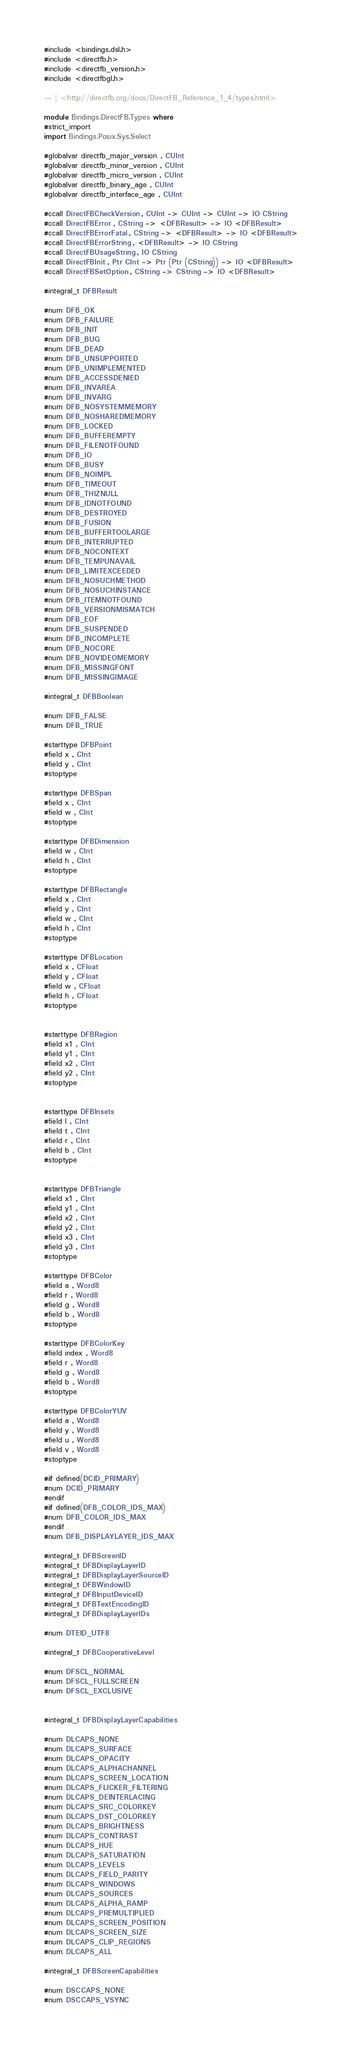Convert code to text. <code><loc_0><loc_0><loc_500><loc_500><_Haskell_>#include <bindings.dsl.h>
#include <directfb.h>
#include <directfb_version.h>
#include <directfbgl.h>

-- | <http://directfb.org/docs/DirectFB_Reference_1_4/types.html>

module Bindings.DirectFB.Types where
#strict_import
import Bindings.Posix.Sys.Select

#globalvar directfb_major_version , CUInt
#globalvar directfb_minor_version , CUInt
#globalvar directfb_micro_version , CUInt
#globalvar directfb_binary_age , CUInt
#globalvar directfb_interface_age , CUInt

#ccall DirectFBCheckVersion , CUInt -> CUInt -> CUInt -> IO CString
#ccall DirectFBError , CString -> <DFBResult> -> IO <DFBResult>
#ccall DirectFBErrorFatal , CString -> <DFBResult> -> IO <DFBResult>
#ccall DirectFBErrorString , <DFBResult> -> IO CString
#ccall DirectFBUsageString , IO CString
#ccall DirectFBInit , Ptr CInt -> Ptr (Ptr (CString)) -> IO <DFBResult>
#ccall DirectFBSetOption , CString -> CString -> IO <DFBResult>

#integral_t DFBResult

#num DFB_OK
#num DFB_FAILURE
#num DFB_INIT
#num DFB_BUG
#num DFB_DEAD
#num DFB_UNSUPPORTED
#num DFB_UNIMPLEMENTED
#num DFB_ACCESSDENIED
#num DFB_INVAREA
#num DFB_INVARG
#num DFB_NOSYSTEMMEMORY
#num DFB_NOSHAREDMEMORY
#num DFB_LOCKED
#num DFB_BUFFEREMPTY
#num DFB_FILENOTFOUND
#num DFB_IO
#num DFB_BUSY
#num DFB_NOIMPL
#num DFB_TIMEOUT
#num DFB_THIZNULL
#num DFB_IDNOTFOUND
#num DFB_DESTROYED
#num DFB_FUSION
#num DFB_BUFFERTOOLARGE
#num DFB_INTERRUPTED
#num DFB_NOCONTEXT
#num DFB_TEMPUNAVAIL
#num DFB_LIMITEXCEEDED
#num DFB_NOSUCHMETHOD
#num DFB_NOSUCHINSTANCE
#num DFB_ITEMNOTFOUND
#num DFB_VERSIONMISMATCH
#num DFB_EOF
#num DFB_SUSPENDED
#num DFB_INCOMPLETE
#num DFB_NOCORE
#num DFB_NOVIDEOMEMORY
#num DFB_MISSINGFONT
#num DFB_MISSINGIMAGE

#integral_t DFBBoolean

#num DFB_FALSE
#num DFB_TRUE

#starttype DFBPoint
#field x , CInt
#field y , CInt
#stoptype

#starttype DFBSpan
#field x , CInt
#field w , CInt
#stoptype

#starttype DFBDimension
#field w , CInt
#field h , CInt
#stoptype

#starttype DFBRectangle
#field x , CInt
#field y , CInt
#field w , CInt
#field h , CInt
#stoptype

#starttype DFBLocation
#field x , CFloat
#field y , CFloat
#field w , CFloat
#field h , CFloat
#stoptype


#starttype DFBRegion
#field x1 , CInt
#field y1 , CInt
#field x2 , CInt
#field y2 , CInt
#stoptype


#starttype DFBInsets
#field l , CInt
#field t , CInt
#field r , CInt
#field b , CInt
#stoptype


#starttype DFBTriangle
#field x1 , CInt
#field y1 , CInt
#field x2 , CInt
#field y2 , CInt
#field x3 , CInt
#field y3 , CInt
#stoptype

#starttype DFBColor
#field a , Word8
#field r , Word8
#field g , Word8
#field b , Word8
#stoptype

#starttype DFBColorKey
#field index , Word8
#field r , Word8
#field g , Word8
#field b , Word8
#stoptype

#starttype DFBColorYUV
#field a , Word8
#field y , Word8
#field u , Word8
#field v , Word8
#stoptype

#if defined(DCID_PRIMARY)
#num DCID_PRIMARY
#endif
#if defined(DFB_COLOR_IDS_MAX)
#num DFB_COLOR_IDS_MAX
#endif
#num DFB_DISPLAYLAYER_IDS_MAX

#integral_t DFBScreenID
#integral_t DFBDisplayLayerID
#integral_t DFBDisplayLayerSourceID
#integral_t DFBWindowID
#integral_t DFBInputDeviceID
#integral_t DFBTextEncodingID
#integral_t DFBDisplayLayerIDs

#num DTEID_UTF8

#integral_t DFBCooperativeLevel

#num DFSCL_NORMAL
#num DFSCL_FULLSCREEN
#num DFSCL_EXCLUSIVE


#integral_t DFBDisplayLayerCapabilities

#num DLCAPS_NONE
#num DLCAPS_SURFACE
#num DLCAPS_OPACITY
#num DLCAPS_ALPHACHANNEL
#num DLCAPS_SCREEN_LOCATION
#num DLCAPS_FLICKER_FILTERING
#num DLCAPS_DEINTERLACING
#num DLCAPS_SRC_COLORKEY
#num DLCAPS_DST_COLORKEY
#num DLCAPS_BRIGHTNESS
#num DLCAPS_CONTRAST
#num DLCAPS_HUE
#num DLCAPS_SATURATION
#num DLCAPS_LEVELS
#num DLCAPS_FIELD_PARITY
#num DLCAPS_WINDOWS
#num DLCAPS_SOURCES
#num DLCAPS_ALPHA_RAMP
#num DLCAPS_PREMULTIPLIED
#num DLCAPS_SCREEN_POSITION
#num DLCAPS_SCREEN_SIZE
#num DLCAPS_CLIP_REGIONS
#num DLCAPS_ALL

#integral_t DFBScreenCapabilities

#num DSCCAPS_NONE
#num DSCCAPS_VSYNC</code> 